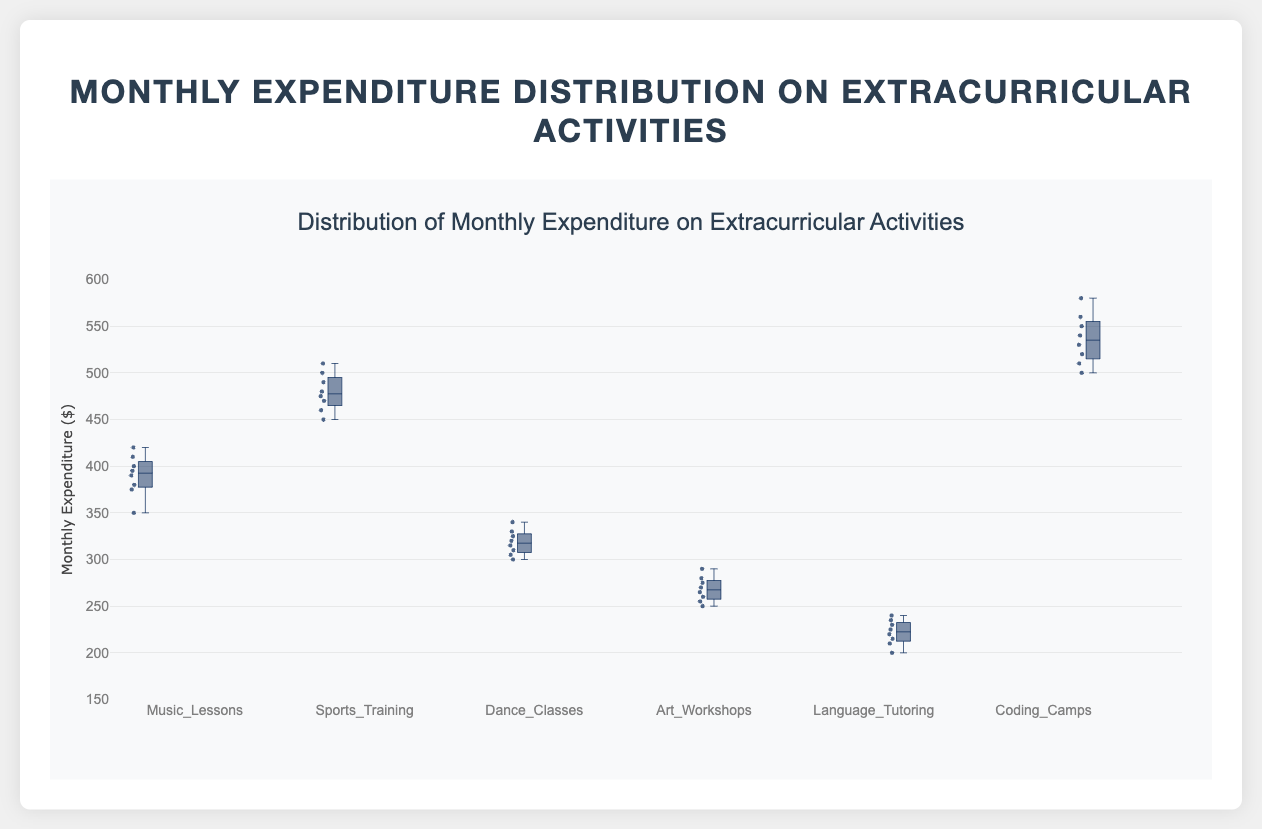What is the title of the figure? The title is located at the top of the figure. It reads "Distribution of Monthly Expenditure on Extracurricular Activities."
Answer: Distribution of Monthly Expenditure on Extracurricular Activities What is the maximum value of expenditure on Coding Camps? From the box plot, the maximum value can be identified as the top whisker of the "Coding Camps" box.
Answer: 580 Which extracurricular activity has the highest median expenditure? The median expenditure is indicated by the line inside each box. "Coding Camps" has the highest median as its line is at the 535 mark.
Answer: Coding Camps How many different categories of extracurricular activities are displayed in the figure? The number of box plots represents the different categories. There are six visible categories: Music Lessons, Sports Training, Dance Classes, Art Workshops, Language Tutoring, and Coding Camps.
Answer: 6 Which activity has the widest range of expenditure values? The range can be determined by the length of each box's whiskers. "Coding Camps" shows the widest range from 500 to 580.
Answer: Coding Camps Compare the third quartile (Q3) of Dance Classes to the first quartile (Q1) of Sports Training. Which is higher? The third quartile (top of the box) for Dance Classes is around 330, and the first quartile (bottom of the box) for Sports Training is about 460. Therefore, the Q3 of Dance Classes is lower than the Q1 of Sports Training.
Answer: Sports Training (Q1 of Sports Training is higher) What is the interquartile range (IQR) of expenditures for Music Lessons? The IQR is calculated by subtracting the first quartile (Q1) from the third quartile (Q3) within the box. For Music Lessons, Q3 is around 410 and Q1 is about 375, so IQR = 410 - 375 = 35.
Answer: 35 Which activity appears to have the smallest variability in expenditures? The activity with the smallest box and shortest whiskers indicates the least variability. Art Workshops have the shortest range between the whiskers.
Answer: Art Workshops Is the median expenditure on Sports Training higher than the third quartile expenditure on Dance Classes? The median for Sports Training is around 475, while the third quartile for Dance Classes is near 330. Thus, the median expenditure for Sports Training is higher.
Answer: Yes What is the minimum expenditure observed in Language Tutoring? The minimum expenditure is indicated by the bottom whisker of the Language Tutoring box, which is at 200.
Answer: 200 